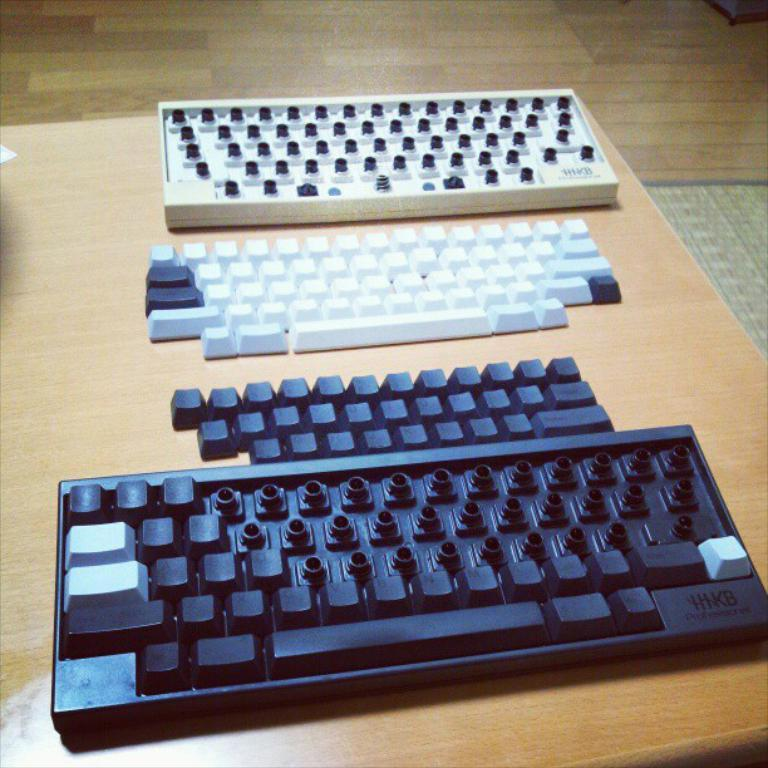<image>
Offer a succinct explanation of the picture presented. A black keyboard has the brand name HHKB on the lower corner. 